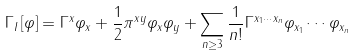<formula> <loc_0><loc_0><loc_500><loc_500>\Gamma _ { I } \left [ \varphi \right ] = \Gamma ^ { x } \varphi _ { x } + \frac { 1 } { 2 } \pi ^ { x y } \varphi _ { x } \varphi _ { y } + \sum _ { n \geq 3 } \frac { 1 } { n ! } \Gamma ^ { x _ { 1 } \cdots x _ { n } } \varphi _ { x _ { 1 } } \cdots \varphi _ { x _ { n } }</formula> 